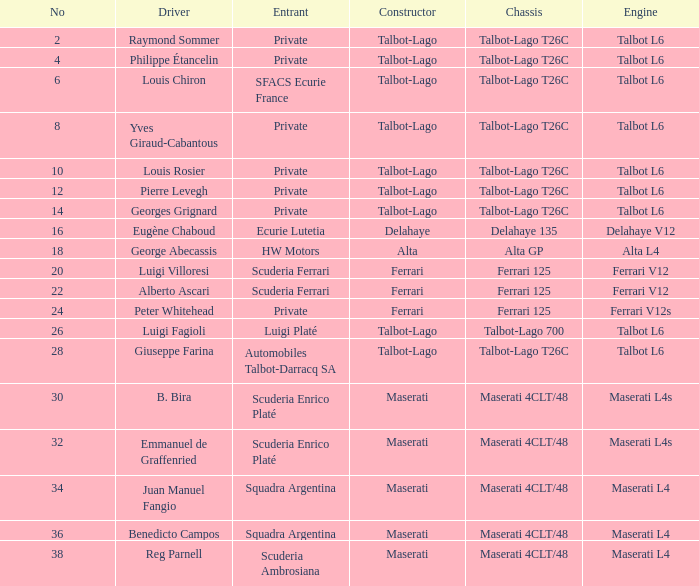Name the engine for ecurie lutetia Delahaye V12. 